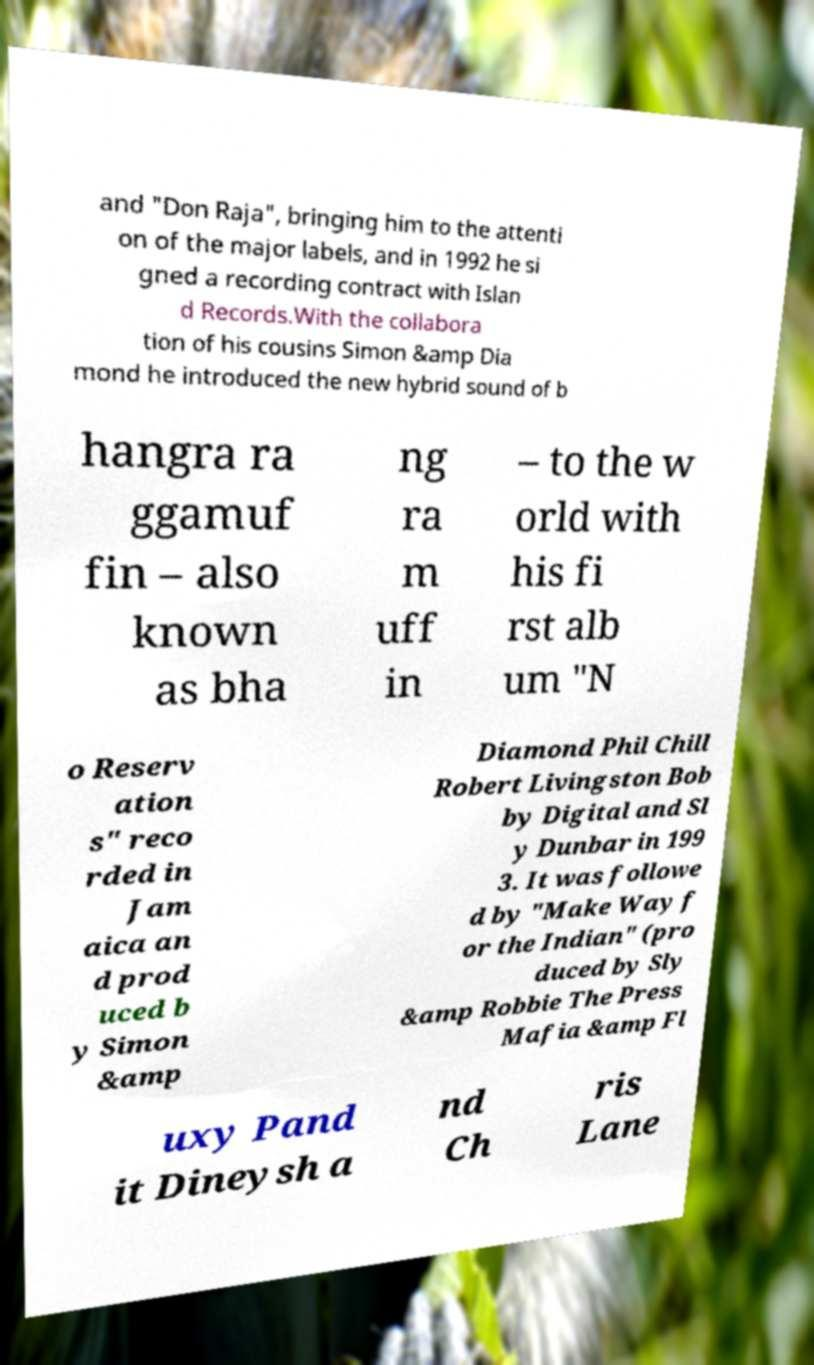For documentation purposes, I need the text within this image transcribed. Could you provide that? and "Don Raja", bringing him to the attenti on of the major labels, and in 1992 he si gned a recording contract with Islan d Records.With the collabora tion of his cousins Simon &amp Dia mond he introduced the new hybrid sound of b hangra ra ggamuf fin – also known as bha ng ra m uff in – to the w orld with his fi rst alb um "N o Reserv ation s" reco rded in Jam aica an d prod uced b y Simon &amp Diamond Phil Chill Robert Livingston Bob by Digital and Sl y Dunbar in 199 3. It was followe d by "Make Way f or the Indian" (pro duced by Sly &amp Robbie The Press Mafia &amp Fl uxy Pand it Dineysh a nd Ch ris Lane 